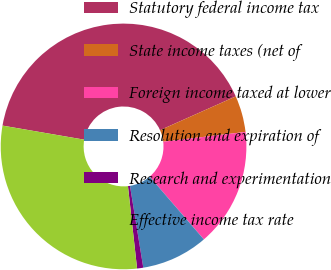Convert chart to OTSL. <chart><loc_0><loc_0><loc_500><loc_500><pie_chart><fcel>Statutory federal income tax<fcel>State income taxes (net of<fcel>Foreign income taxed at lower<fcel>Resolution and expiration of<fcel>Research and experimentation<fcel>Effective income tax rate<nl><fcel>40.61%<fcel>4.79%<fcel>15.55%<fcel>8.77%<fcel>0.81%<fcel>29.47%<nl></chart> 